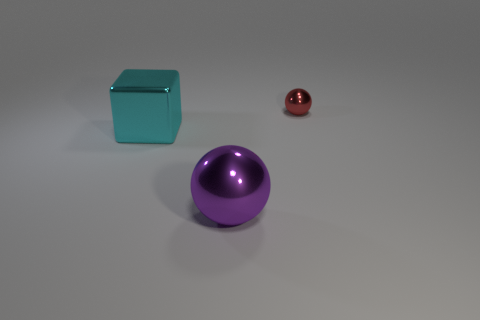Is there any other thing that is the same shape as the big cyan metal thing?
Your answer should be compact. No. What shape is the large shiny object to the right of the large thing left of the purple sphere?
Make the answer very short. Sphere. What is the shape of the big thing that is made of the same material as the big sphere?
Your answer should be compact. Cube. How big is the thing that is in front of the large shiny thing that is behind the large purple sphere?
Provide a succinct answer. Large. What shape is the large purple metallic object?
Offer a very short reply. Sphere. How many large objects are either metallic things or blocks?
Your answer should be compact. 2. What is the size of the other shiny object that is the same shape as the small red object?
Your answer should be compact. Large. What number of balls are both to the left of the red sphere and behind the large purple shiny ball?
Your answer should be compact. 0. There is a purple thing; is it the same shape as the object left of the big purple thing?
Your answer should be very brief. No. Are there more purple balls that are to the left of the purple metal sphere than cyan metal blocks?
Provide a succinct answer. No. 